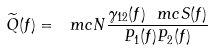<formula> <loc_0><loc_0><loc_500><loc_500>\widetilde { Q } ( f ) = \ m c { N } \frac { \gamma _ { 1 2 } ( f ) \ m c { S } ( f ) } { P _ { 1 } ( f ) P _ { 2 } ( f ) }</formula> 